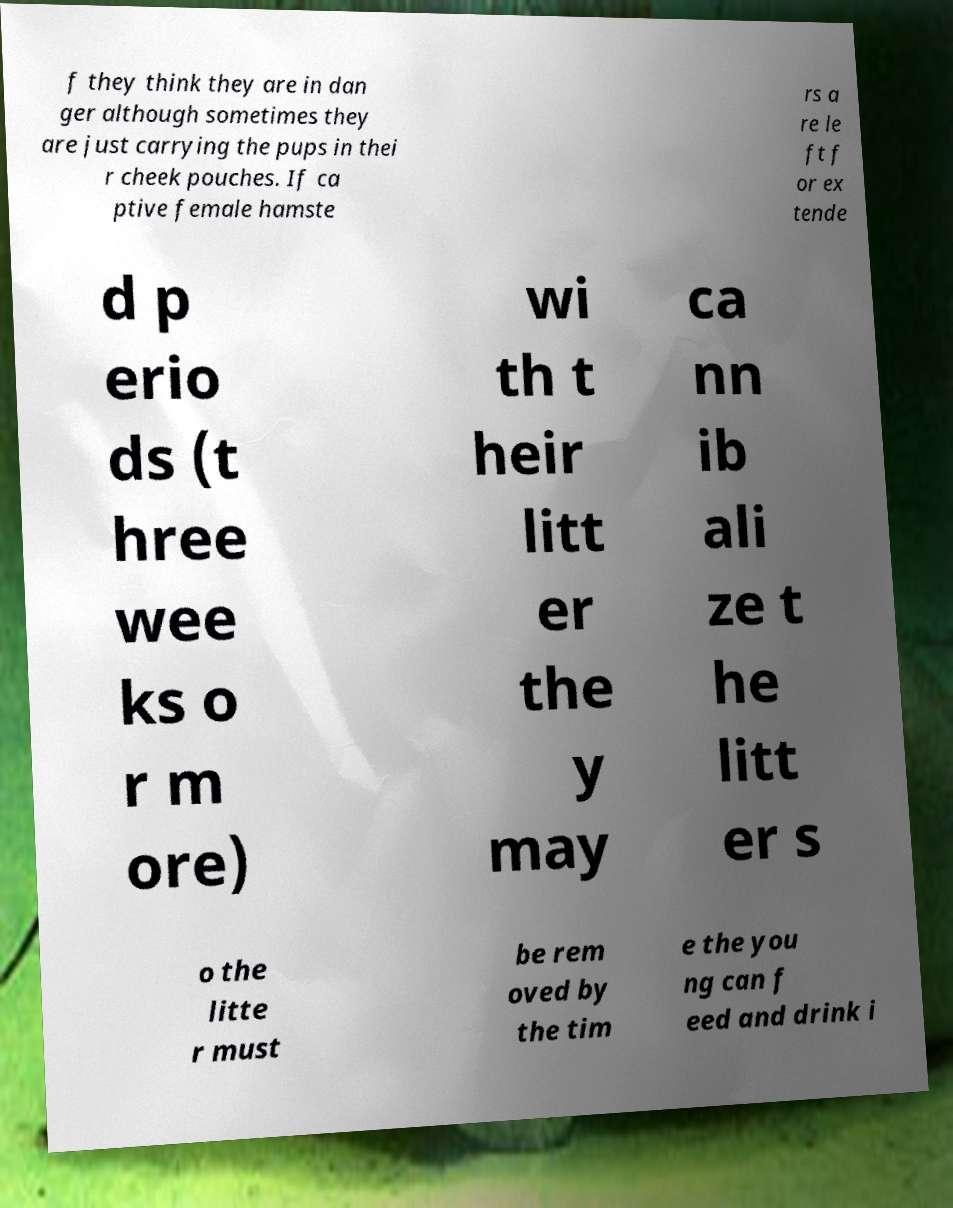I need the written content from this picture converted into text. Can you do that? f they think they are in dan ger although sometimes they are just carrying the pups in thei r cheek pouches. If ca ptive female hamste rs a re le ft f or ex tende d p erio ds (t hree wee ks o r m ore) wi th t heir litt er the y may ca nn ib ali ze t he litt er s o the litte r must be rem oved by the tim e the you ng can f eed and drink i 